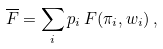Convert formula to latex. <formula><loc_0><loc_0><loc_500><loc_500>\overline { F } = \sum _ { i } p _ { i } \, F ( \pi _ { i } , w _ { i } ) \, ,</formula> 